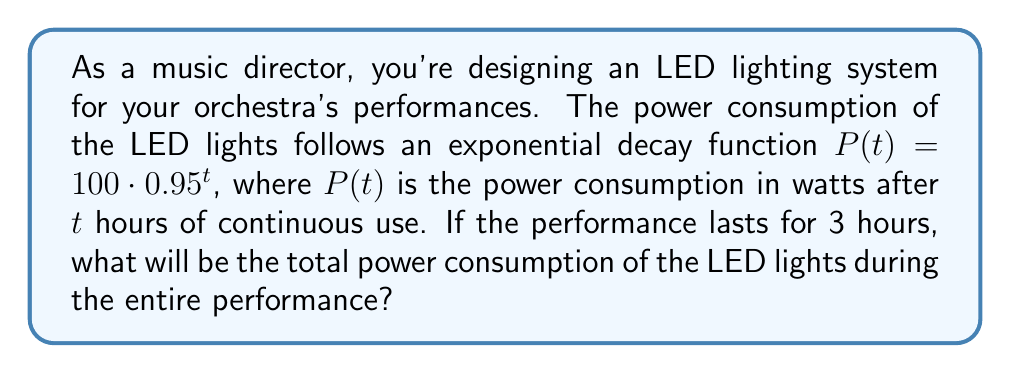Can you answer this question? To solve this problem, we need to calculate the total power consumption over the 3-hour period. Since the power consumption changes continuously, we need to use integration.

1. The power consumption function is given by:
   $P(t) = 100 \cdot 0.95^t$

2. To find the total power consumption, we need to integrate this function from $t=0$ to $t=3$:
   $\text{Total Power} = \int_0^3 100 \cdot 0.95^t dt$

3. Let's solve this integral:
   $\int_0^3 100 \cdot 0.95^t dt = 100 \cdot \int_0^3 0.95^t dt$

4. The integral of an exponential function is:
   $\int a^x dx = \frac{a^x}{\ln(a)} + C$

5. Applying this to our problem:
   $100 \cdot \int_0^3 0.95^t dt = \frac{100}{\ln(0.95)} \cdot 0.95^t \Big|_0^3$

6. Evaluating the integral:
   $= \frac{100}{\ln(0.95)} \cdot (0.95^3 - 0.95^0)$
   $= \frac{100}{\ln(0.95)} \cdot (0.857375 - 1)$
   $= \frac{100}{\ln(0.95)} \cdot (-0.142625)$

7. Calculate the final result:
   $\approx 278.26$ watt-hours

Therefore, the total power consumption during the 3-hour performance is approximately 278.26 watt-hours.
Answer: 278.26 watt-hours 